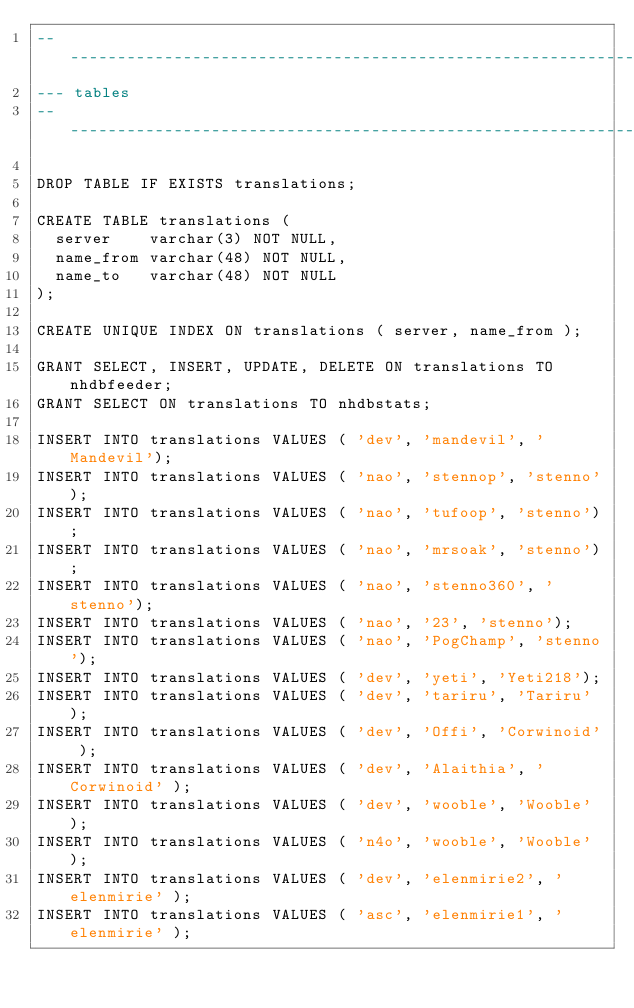<code> <loc_0><loc_0><loc_500><loc_500><_SQL_>----------------------------------------------------------------------------
--- tables 
----------------------------------------------------------------------------

DROP TABLE IF EXISTS translations;

CREATE TABLE translations (
  server    varchar(3) NOT NULL,
  name_from varchar(48) NOT NULL,
  name_to   varchar(48) NOT NULL
);

CREATE UNIQUE INDEX ON translations ( server, name_from );

GRANT SELECT, INSERT, UPDATE, DELETE ON translations TO nhdbfeeder;
GRANT SELECT ON translations TO nhdbstats;

INSERT INTO translations VALUES ( 'dev', 'mandevil', 'Mandevil');
INSERT INTO translations VALUES ( 'nao', 'stennop', 'stenno');
INSERT INTO translations VALUES ( 'nao', 'tufoop', 'stenno');
INSERT INTO translations VALUES ( 'nao', 'mrsoak', 'stenno');
INSERT INTO translations VALUES ( 'nao', 'stenno360', 'stenno');
INSERT INTO translations VALUES ( 'nao', '23', 'stenno');
INSERT INTO translations VALUES ( 'nao', 'PogChamp', 'stenno');
INSERT INTO translations VALUES ( 'dev', 'yeti', 'Yeti218');
INSERT INTO translations VALUES ( 'dev', 'tariru', 'Tariru' );
INSERT INTO translations VALUES ( 'dev', 'Offi', 'Corwinoid' );
INSERT INTO translations VALUES ( 'dev', 'Alaithia', 'Corwinoid' );
INSERT INTO translations VALUES ( 'dev', 'wooble', 'Wooble' );
INSERT INTO translations VALUES ( 'n4o', 'wooble', 'Wooble' );
INSERT INTO translations VALUES ( 'dev', 'elenmirie2', 'elenmirie' );
INSERT INTO translations VALUES ( 'asc', 'elenmirie1', 'elenmirie' );</code> 